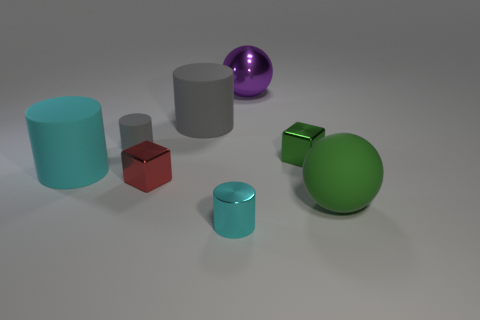What is the lighting situation like in this scene? The lighting in the scene seems diffuse, with soft shadows indicating a probable overhead light source. The lack of harsh shadows and highlights suggests an even distribution of light throughout. 